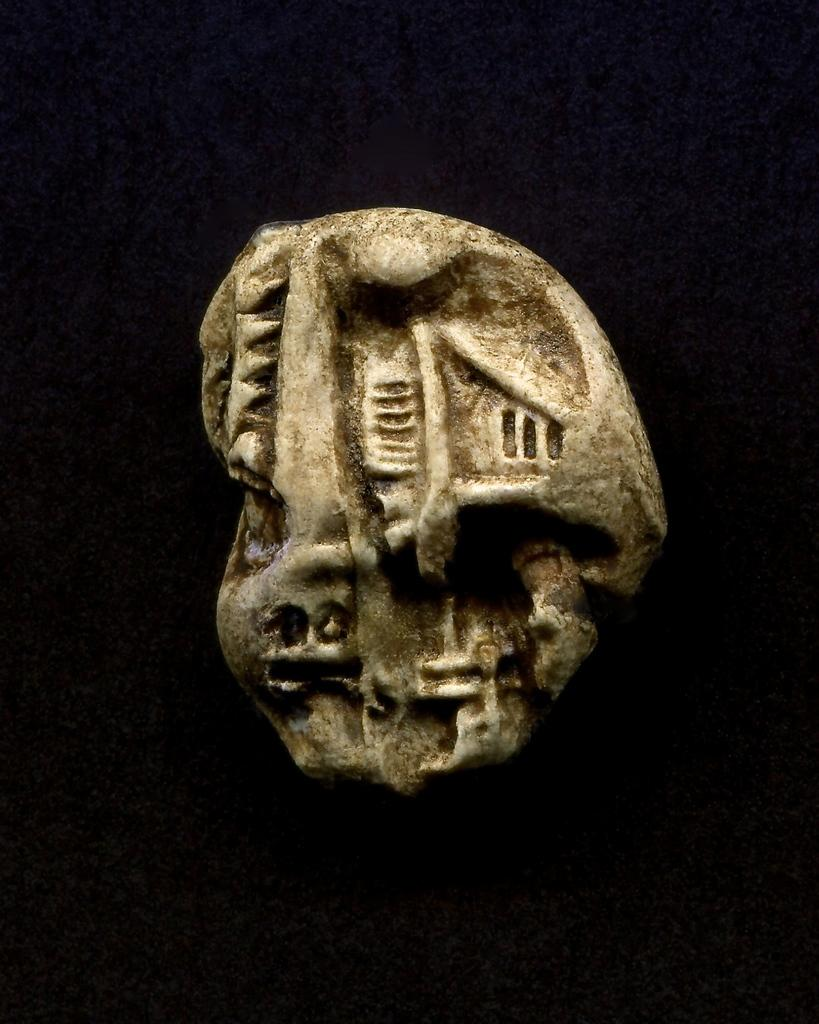What is the main subject of the image? There is a stone carved statue in the image. What can be observed about the background of the image? The background of the image is black in color. Can you see a bridge made of leather in the image? No, there is no bridge or leather present in the image. The image features a stone carved statue with a black background. 